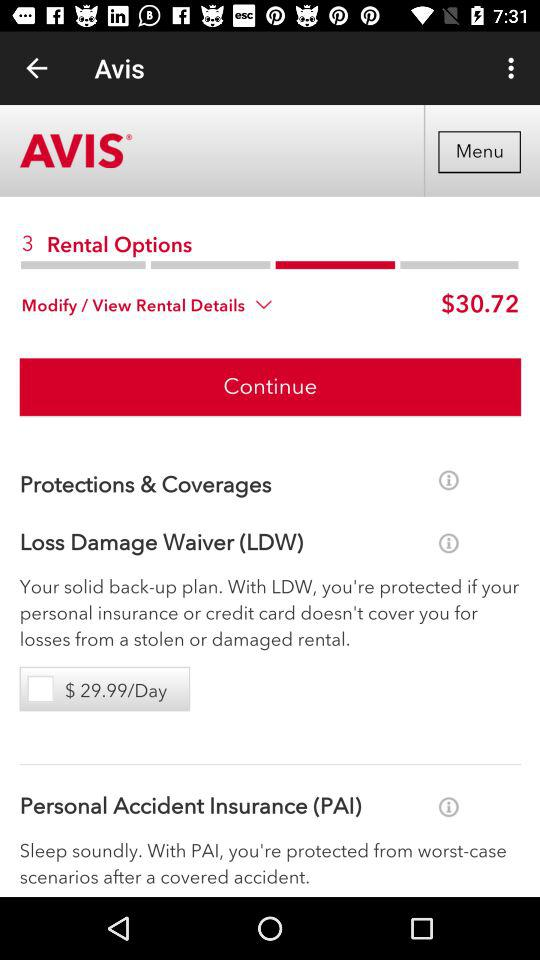What is the full form of PAI? The full form of PAI is "Personal Accident Insurance ". 